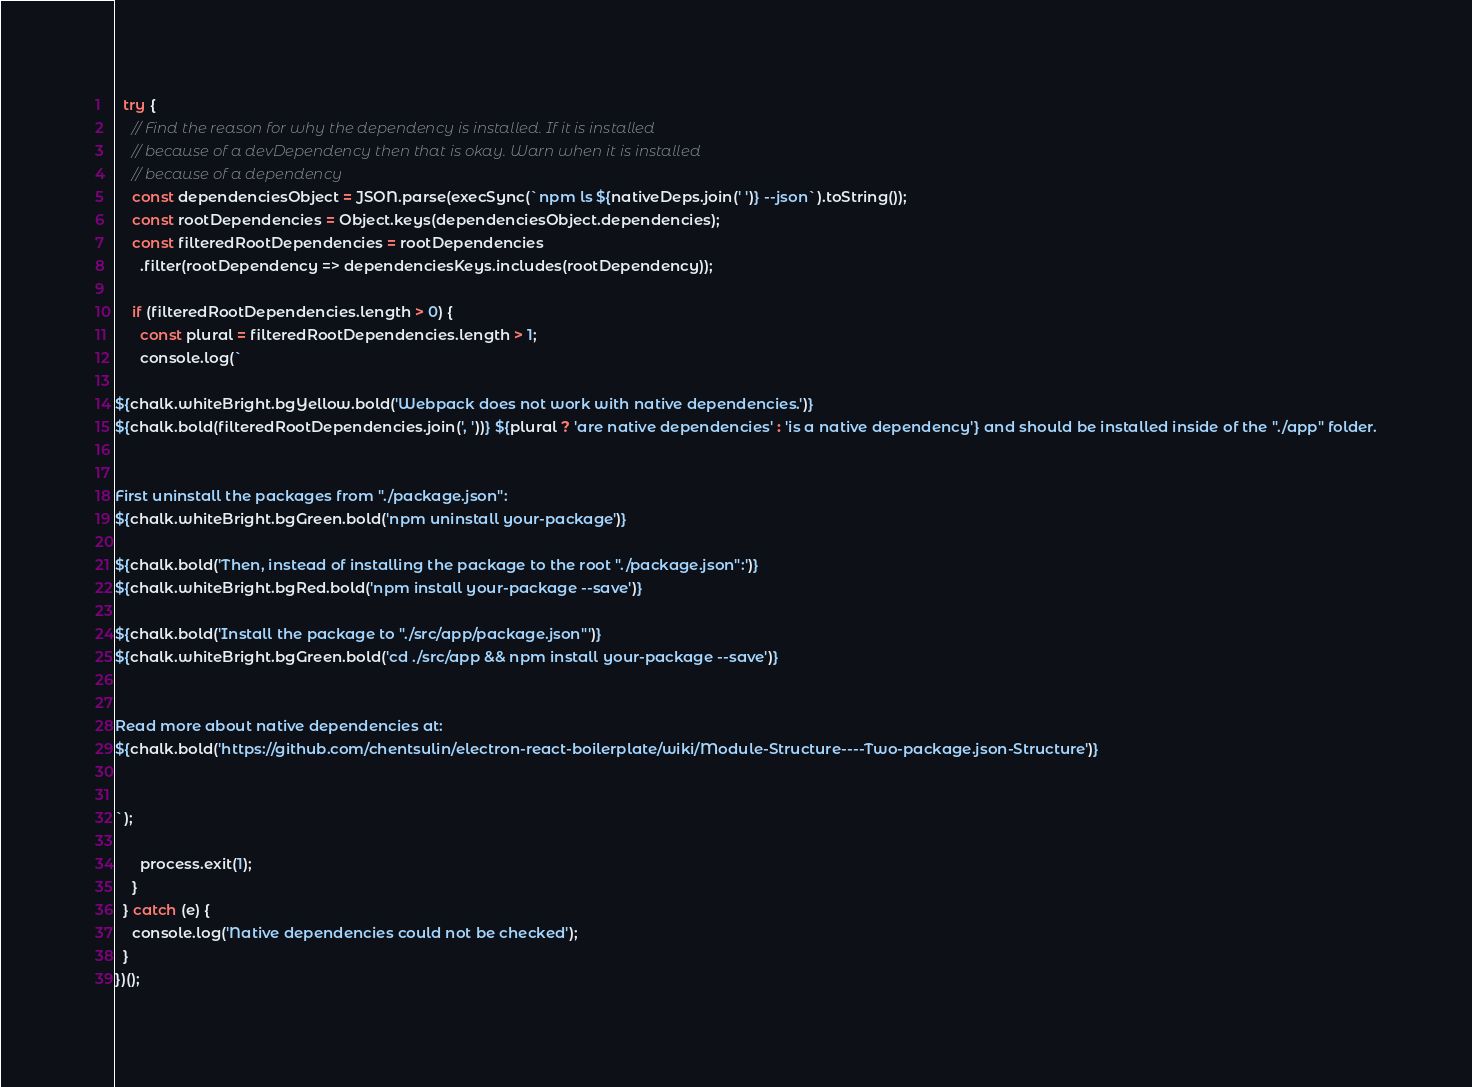<code> <loc_0><loc_0><loc_500><loc_500><_JavaScript_>  try {
    // Find the reason for why the dependency is installed. If it is installed
    // because of a devDependency then that is okay. Warn when it is installed
    // because of a dependency
    const dependenciesObject = JSON.parse(execSync(`npm ls ${nativeDeps.join(' ')} --json`).toString());
    const rootDependencies = Object.keys(dependenciesObject.dependencies);
    const filteredRootDependencies = rootDependencies
      .filter(rootDependency => dependenciesKeys.includes(rootDependency));

    if (filteredRootDependencies.length > 0) {
      const plural = filteredRootDependencies.length > 1;
      console.log(`

${chalk.whiteBright.bgYellow.bold('Webpack does not work with native dependencies.')}
${chalk.bold(filteredRootDependencies.join(', '))} ${plural ? 'are native dependencies' : 'is a native dependency'} and should be installed inside of the "./app" folder.


First uninstall the packages from "./package.json":
${chalk.whiteBright.bgGreen.bold('npm uninstall your-package')}

${chalk.bold('Then, instead of installing the package to the root "./package.json":')}
${chalk.whiteBright.bgRed.bold('npm install your-package --save')}

${chalk.bold('Install the package to "./src/app/package.json"')}
${chalk.whiteBright.bgGreen.bold('cd ./src/app && npm install your-package --save')}


Read more about native dependencies at:
${chalk.bold('https://github.com/chentsulin/electron-react-boilerplate/wiki/Module-Structure----Two-package.json-Structure')}


`);

      process.exit(1);
    }
  } catch (e) {
    console.log('Native dependencies could not be checked');
  }
})();
</code> 